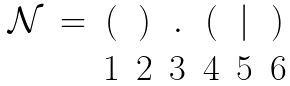Convert formula to latex. <formula><loc_0><loc_0><loc_500><loc_500>\begin{matrix} \mathcal { N } & = & ( & ) & . & ( & | & ) \\ & & 1 & 2 & 3 & 4 & 5 & 6 \end{matrix}</formula> 